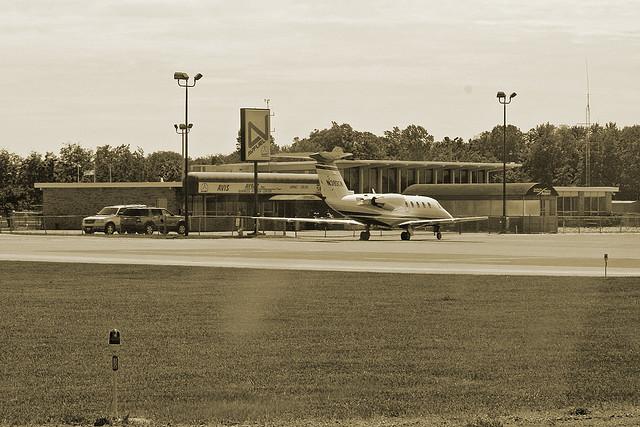Is the airplane ready for takeoff?
Be succinct. No. Where is this picture taken?
Short answer required. Airport. Is the aircraft off the runway?
Be succinct. Yes. 